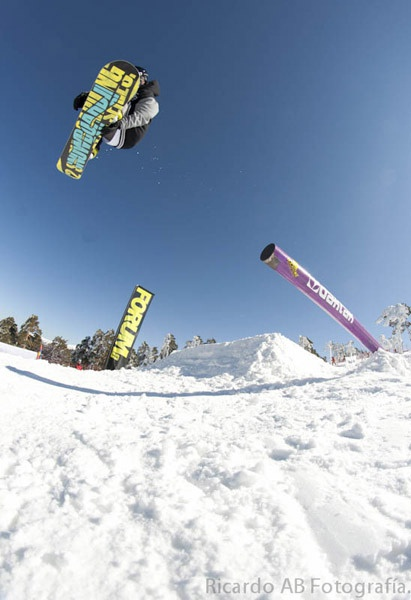Describe the objects in this image and their specific colors. I can see snowboard in blue, khaki, gray, black, and lightblue tones, people in blue, black, gray, darkgray, and lightgray tones, and people in blue, gray, salmon, maroon, and brown tones in this image. 